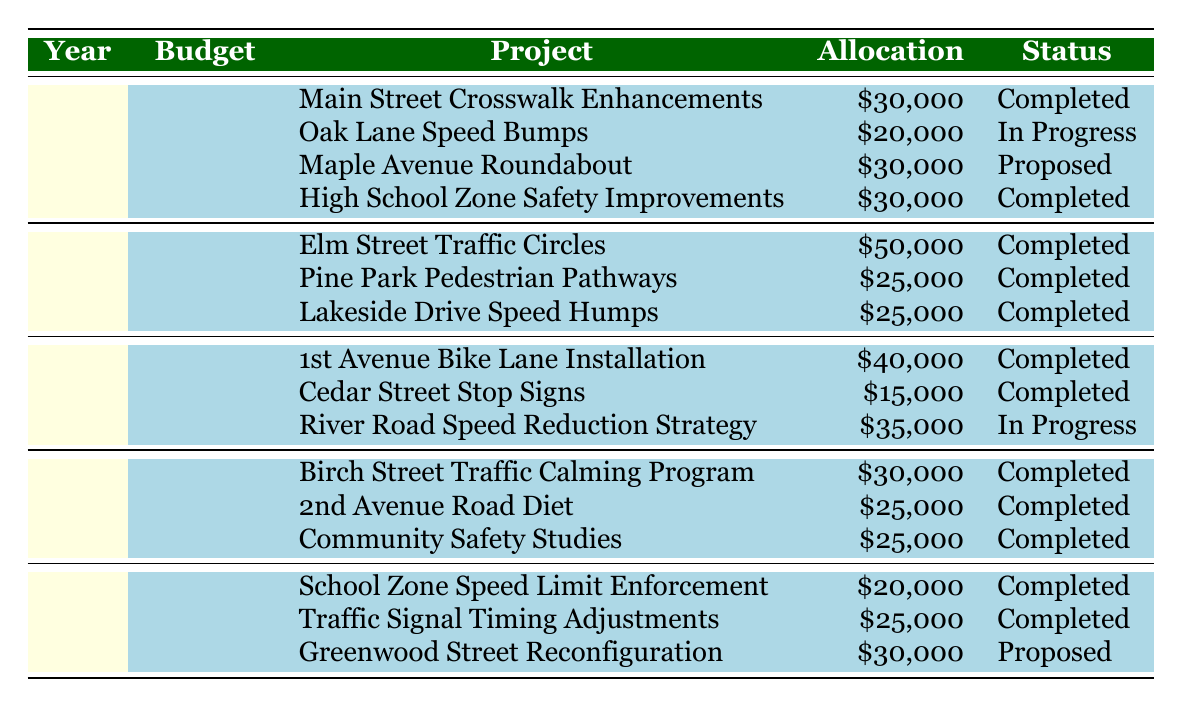what is the total budget allocated for traffic calming projects in 2023? In 2023, the City Council approved a total budget of $120,000 for traffic calming projects, which can be directly found in the table under the 2023 row.
Answer: 120000 how many traffic calming projects were proposed in 2021? In 2021, there were three projects listed. Among them, only the "River Road Speed Reduction Strategy" is marked as "In Progress," while the other two are completed, and no proposed projects are listed. Therefore, there were zero proposed projects that year.
Answer: 0 what is the total amount allocated across all projects in 2022? In 2022, the total budget allocated to projects is the sum of the allocated budgets: $50,000 (Elm Street) + $25,000 (Pine Park) + $25,000 (Lakeside Drive) = $100,000. Therefore, the total amount allocated is $100,000, which is consistent with the City Council's budget for that year.
Answer: 100000 did the budget for traffic calming projects increase from 2019 to 2020? The budget for 2019 was $75,000 and for 2020 it was $80,000. To determine if the budget increased, we compare these two values: $80,000 is greater than $75,000, confirming that the budget did increase from 2019 to 2020.
Answer: Yes which year had the most completed projects? Counting the completed projects in each year: 2023 has 2, 2022 has 3, 2021 has 2, 2020 has 3, and 2019 has 2 completed projects. Since both 2022 and 2020 have 3 completed projects, we conclude either could be considered the year with the most completed projects.
Answer: 2022 and 2020 what is the average allocation for all projects across the past five years? To find the average allocated budget, we first sum all allocated budgets for each year from the data provided. The total allocation is $30,000 + $20,000 + $30,000 + $30,000 (2023) + $50,000 + $25,000 + $25,000 (2022) + $40,000 + $15,000 + $35,000 (2021) + $30,000 + $25,000 + $25,000 (2020) + $20,000 + $25,000 + $30,000 (2019) = $425,000. With a total of 15 projects, dividing $425,000 by 15 yields an average allocation of approximately $28,333.33 per project.
Answer: 28333.33 how many traffic calming measures are still in progress as of 2023? Checking through each year, in 2023, there is one project "Oak Lane Speed Bumps" listed as "In Progress," and in 2021, "River Road Speed Reduction Strategy" is also marked as "In Progress." Therefore, there are two projects that remain in progress as of the end of 2023.
Answer: 2 in which year were the least amount of funds allocated to traffic calming projects? Reviewing each year's budget, 2019 had the lowest budget allocation at $75,000 compared to $80,000 (2020), $90,000 (2021), $100,000 (2022), and $120,000 (2023). Therefore, the least amount of funds were allocated in 2019.
Answer: 2019 